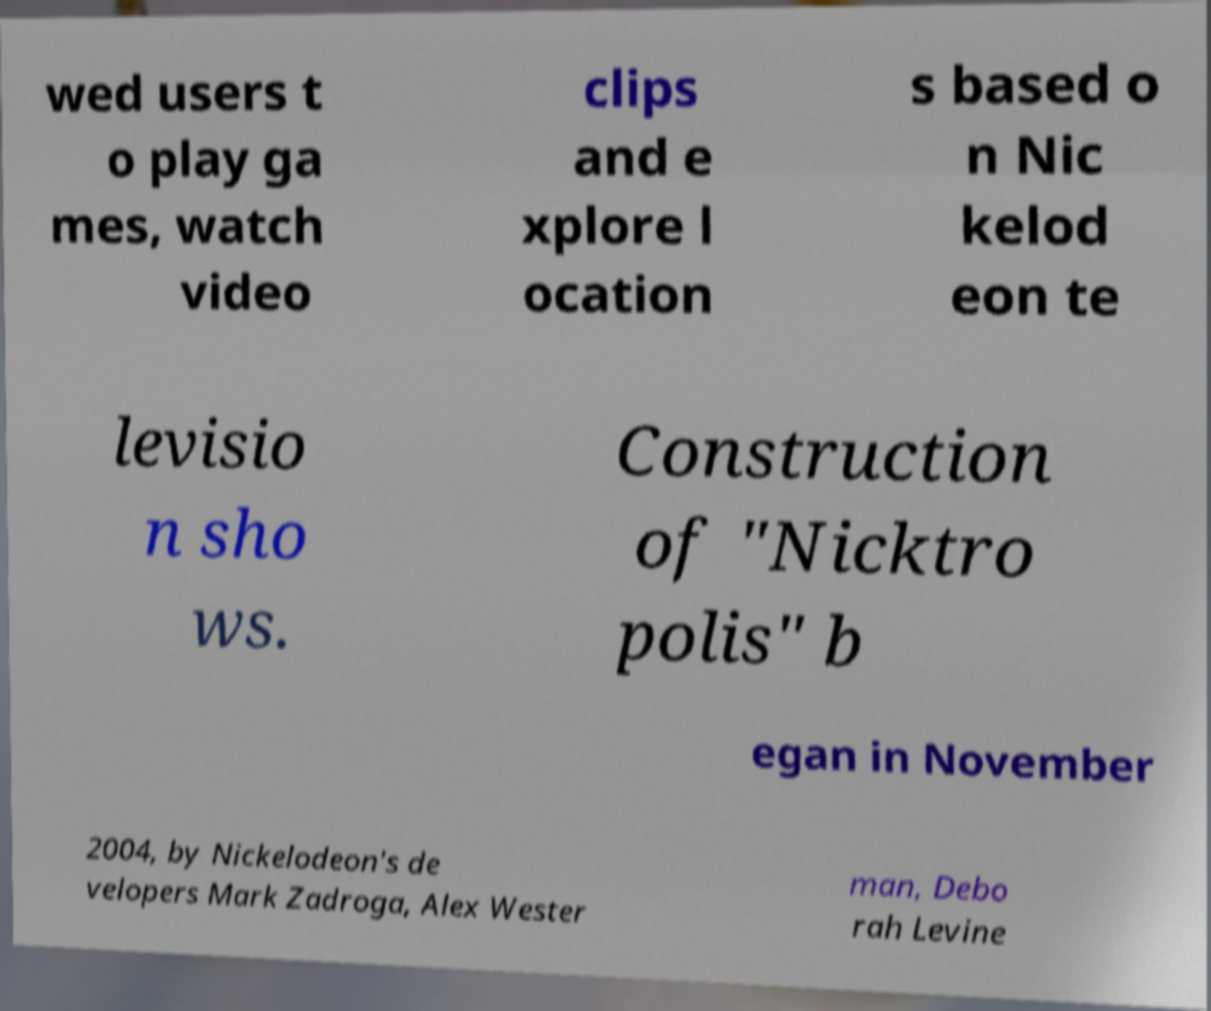Please read and relay the text visible in this image. What does it say? wed users t o play ga mes, watch video clips and e xplore l ocation s based o n Nic kelod eon te levisio n sho ws. Construction of "Nicktro polis" b egan in November 2004, by Nickelodeon's de velopers Mark Zadroga, Alex Wester man, Debo rah Levine 